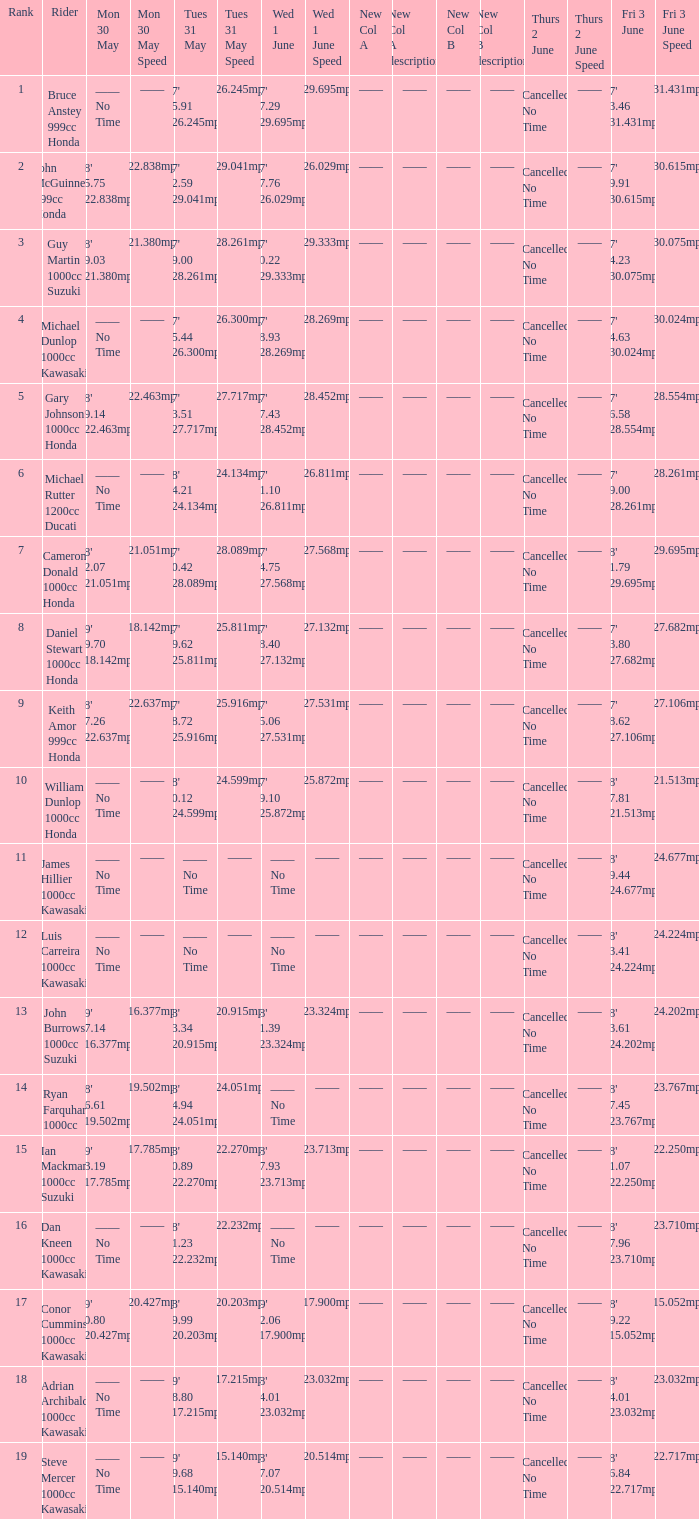What is the Fri 3 June time for the rider whose Tues 31 May time was 19' 18.80 117.215mph? 18' 24.01 123.032mph. 